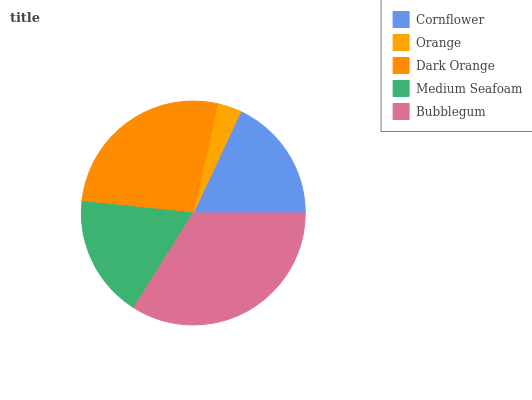Is Orange the minimum?
Answer yes or no. Yes. Is Bubblegum the maximum?
Answer yes or no. Yes. Is Dark Orange the minimum?
Answer yes or no. No. Is Dark Orange the maximum?
Answer yes or no. No. Is Dark Orange greater than Orange?
Answer yes or no. Yes. Is Orange less than Dark Orange?
Answer yes or no. Yes. Is Orange greater than Dark Orange?
Answer yes or no. No. Is Dark Orange less than Orange?
Answer yes or no. No. Is Cornflower the high median?
Answer yes or no. Yes. Is Cornflower the low median?
Answer yes or no. Yes. Is Dark Orange the high median?
Answer yes or no. No. Is Dark Orange the low median?
Answer yes or no. No. 